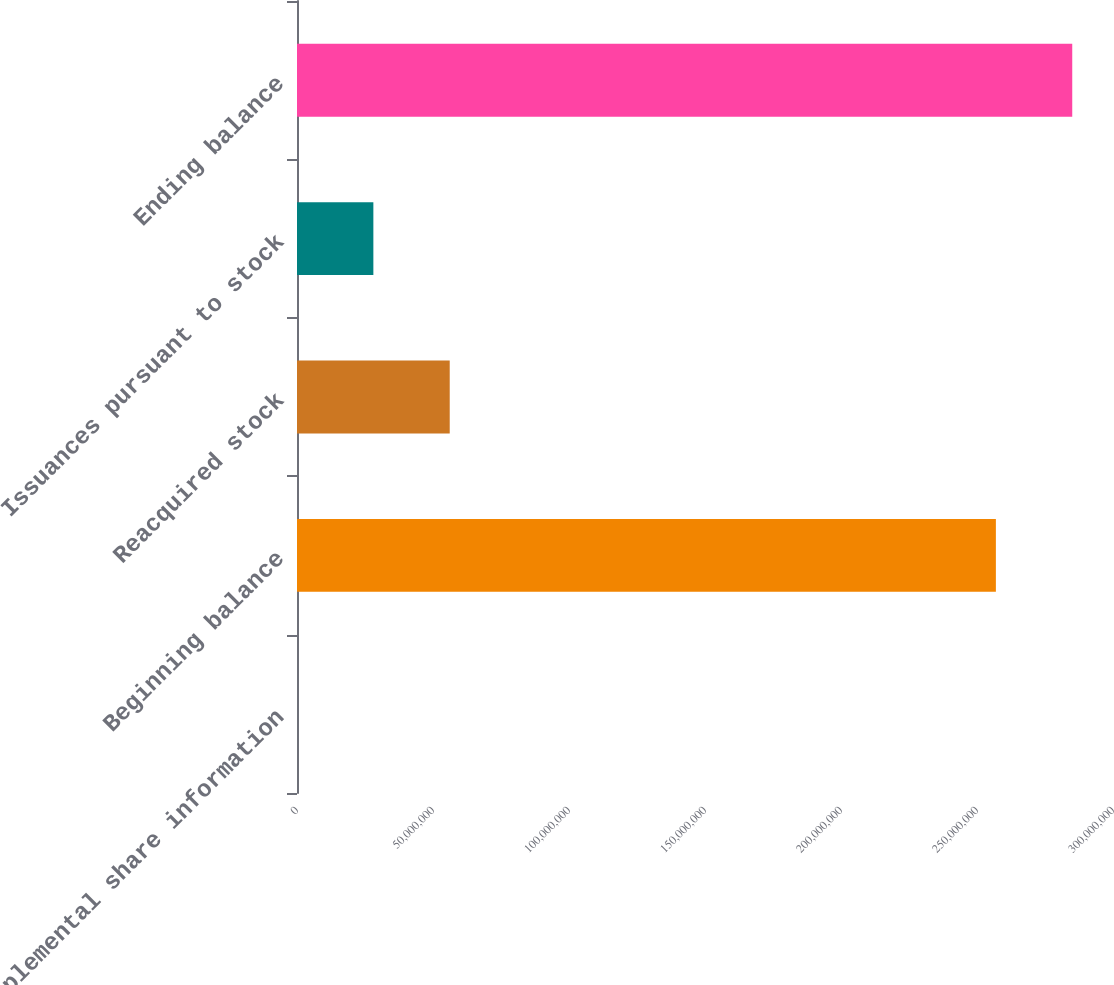<chart> <loc_0><loc_0><loc_500><loc_500><bar_chart><fcel>Supplemental share information<fcel>Beginning balance<fcel>Reacquired stock<fcel>Issuances pursuant to stock<fcel>Ending balance<nl><fcel>2013<fcel>2.56941e+08<fcel>5.6149e+07<fcel>2.80755e+07<fcel>2.85015e+08<nl></chart> 